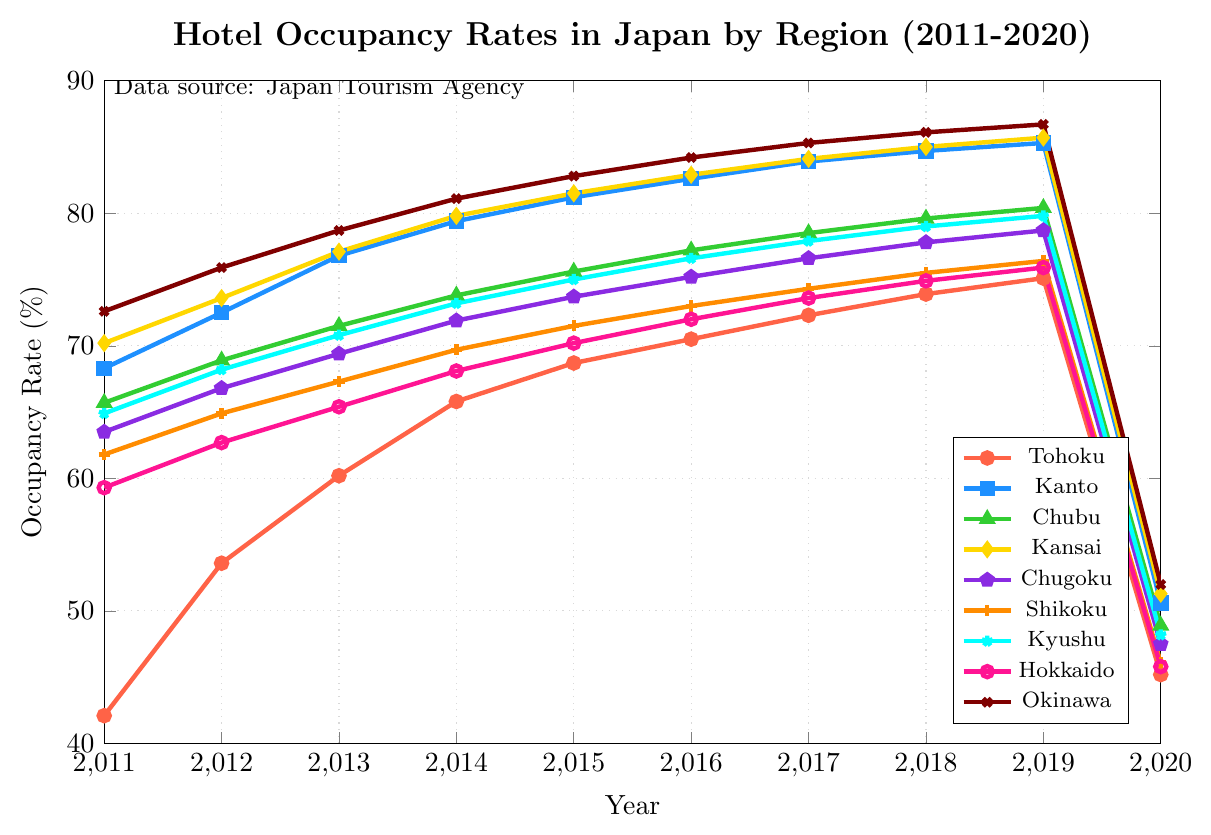What region had the highest occupancy rate in 2019? To find the highest occupancy rate in 2019, look at the y-values corresponding to 2019 for all regions. The highest value is 86.7% for Okinawa.
Answer: Okinawa How much did the occupancy rate change in Tohoku from 2011 to 2020? Calculate the difference between the occupancy rates in 2020 and 2011 for Tohoku. It is 45.2% - 42.1% = 3.1%.
Answer: 3.1% Which region had the largest drop in occupancy rate between 2019 and 2020? Compare the differences in occupancy rates for each region between 2019 and 2020. The largest drop is found for the Kanto region, dropping from 85.3% to 50.6%, a difference of 34.7%.
Answer: Kanto What is the average occupancy rate for Shikoku across the years 2011 to 2020? Sum the occupancy rates for Shikoku from 2011 to 2020 and divide by the number of years. The sum is 61.8 + 64.9 + 67.3 + 69.7 + 71.5 + 73.0 + 74.3 + 75.5 + 76.4 + 46.1 = 680.5. Divide by 10 to get the average: 680.5 / 10 = 68.05%.
Answer: 68.05% Between 2011 and 2019, which region experienced the greatest increase in occupancy rate? Calculate the difference in occupancy rates between 2011 and 2019 for each region. Okinawa had the greatest increase from 72.6% to 86.7%, an increase of 14.1%.
Answer: Okinawa What was the occupancy rate in Kansai in 2017? Locate the Kansai series and find the y-value for the year 2017, which is 84.1%.
Answer: 84.1% Which regions had occupancy rates higher than 80% in 2018? Identify the regions with y-values greater than 80% in 2018. The regions are Kanto (84.7%), Kansai (85.0%), and Okinawa (86.1%).
Answer: Kanto, Kansai, Okinawa By how much did the occupancy rate for Chubu increase from 2011 to 2015? Calculate the difference between occupancy rates in 2015 and 2011 for Chubu. It is 75.6% - 65.7% = 9.9%.
Answer: 9.9% Which region had the lowest occupancy rate in 2016? Find the lowest y-value for 2016 across all regions. The lowest value is 70.5% for Tohoku.
Answer: Tohoku What pattern can be observed in the Tohoku region from 2011 to 2019, and what happened in 2020? From 2011 to 2019, Tohoku shows a consistent increase in occupancy rate, rising from 42.1% to 75.1%. In 2020, there is a significant drop to 45.2%.
Answer: Consistent increase until 2019, significant drop in 2020 